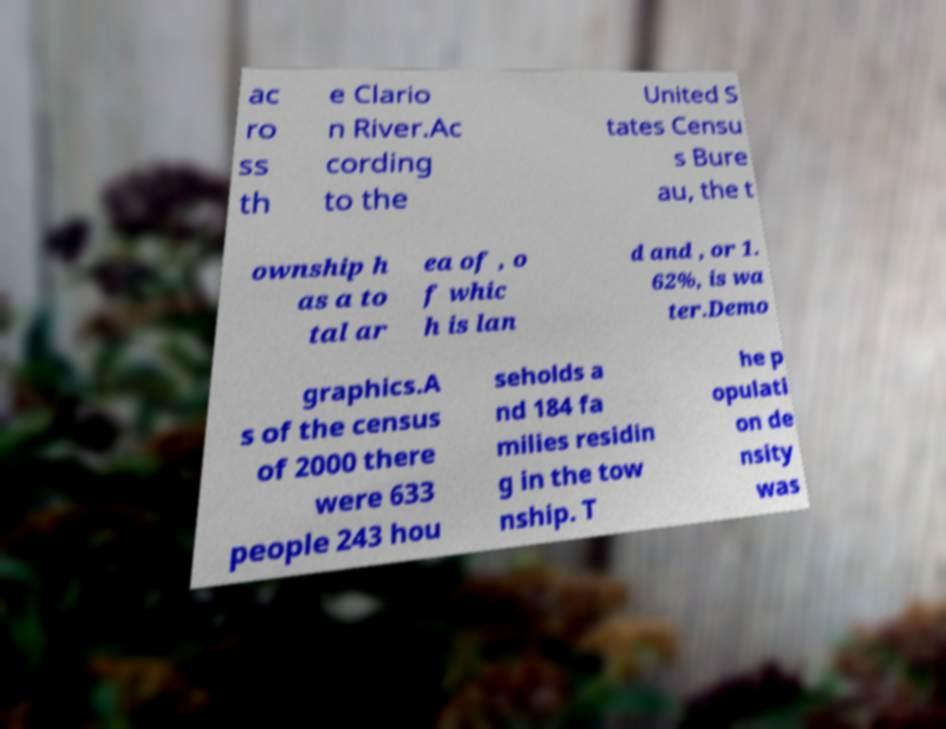Can you read and provide the text displayed in the image?This photo seems to have some interesting text. Can you extract and type it out for me? ac ro ss th e Clario n River.Ac cording to the United S tates Censu s Bure au, the t ownship h as a to tal ar ea of , o f whic h is lan d and , or 1. 62%, is wa ter.Demo graphics.A s of the census of 2000 there were 633 people 243 hou seholds a nd 184 fa milies residin g in the tow nship. T he p opulati on de nsity was 